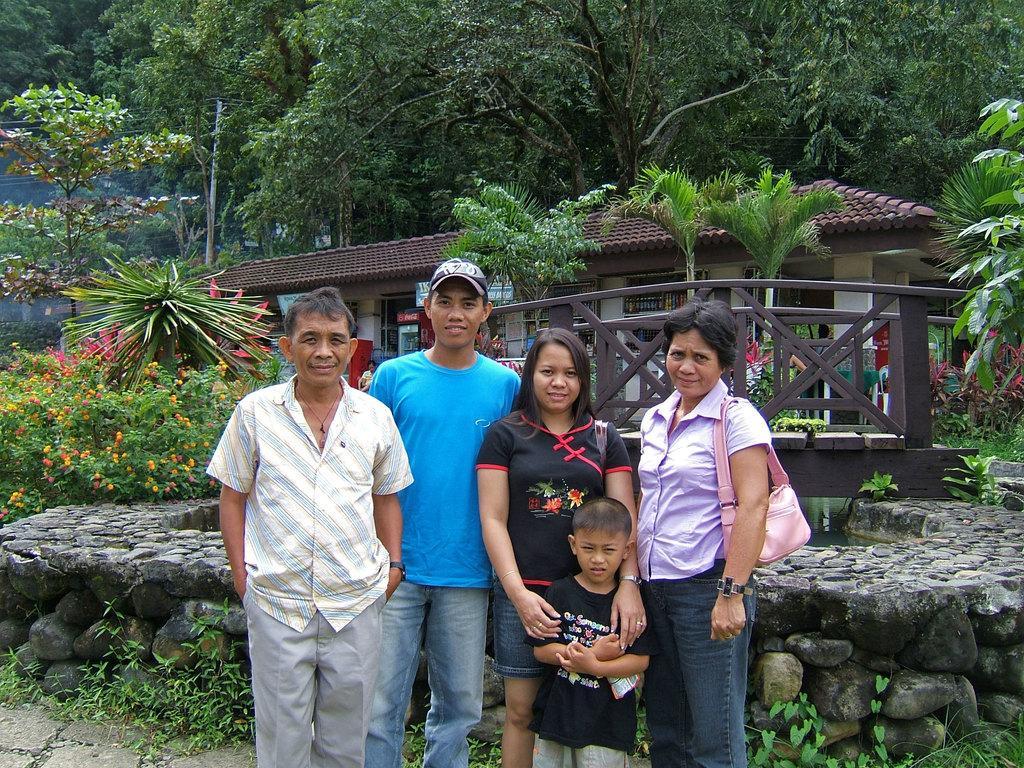Could you give a brief overview of what you see in this image? In this image we can see a group of people standing. A boy is holding an object in the image. We can see a lady wearing a handbag at the right side of the image. There are many trees and plants in the image. We can see a bridge in the image. We can see some water under the bridge. There is an electrical pole and few cables connected to it. There are many flowers to a plant at the left side of the image. 